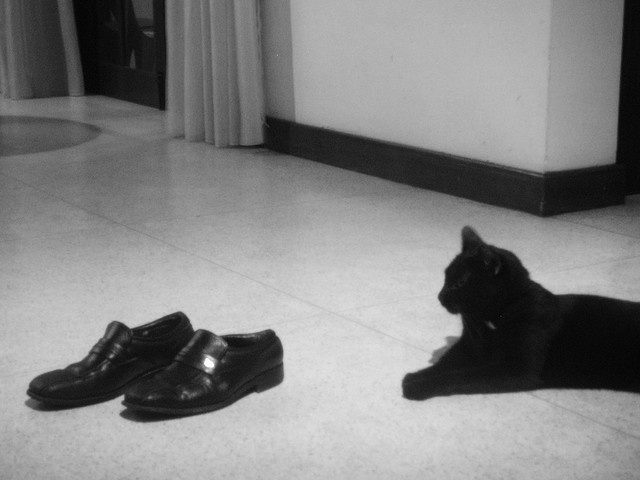Describe the objects in this image and their specific colors. I can see a cat in gray, black, darkgray, and lightgray tones in this image. 